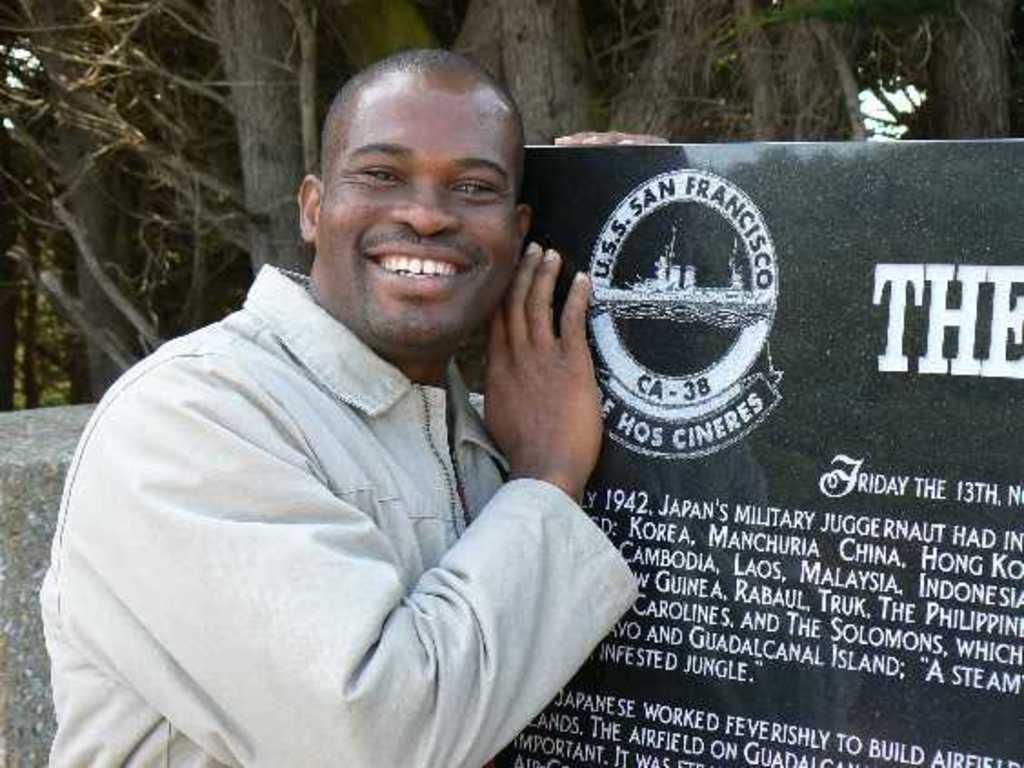Please provide a concise description of this image. In this image I can see a person standing, laughing and posing for the picture. He is holding a board on the right hand side with some text. I can see trees behind him and a wall. 